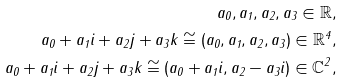<formula> <loc_0><loc_0><loc_500><loc_500>a _ { 0 } , a _ { 1 } , a _ { 2 } , a _ { 3 } \in \mathbb { R } , \\ a _ { 0 } + a _ { 1 } i + a _ { 2 } j + a _ { 3 } k \cong ( a _ { 0 } , a _ { 1 } , a _ { 2 } , a _ { 3 } ) \in \mathbb { R } ^ { 4 } , \\ a _ { 0 } + a _ { 1 } i + a _ { 2 } j + a _ { 3 } k \cong ( a _ { 0 } + a _ { 1 } i , a _ { 2 } - a _ { 3 } i ) \in \mathbb { C } ^ { 2 } ,</formula> 